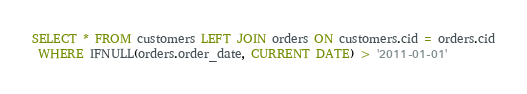Convert code to text. <code><loc_0><loc_0><loc_500><loc_500><_SQL_>SELECT * FROM customers LEFT JOIN orders ON customers.cid = orders.cid
 WHERE IFNULL(orders.order_date, CURRENT DATE) > '2011-01-01'
</code> 